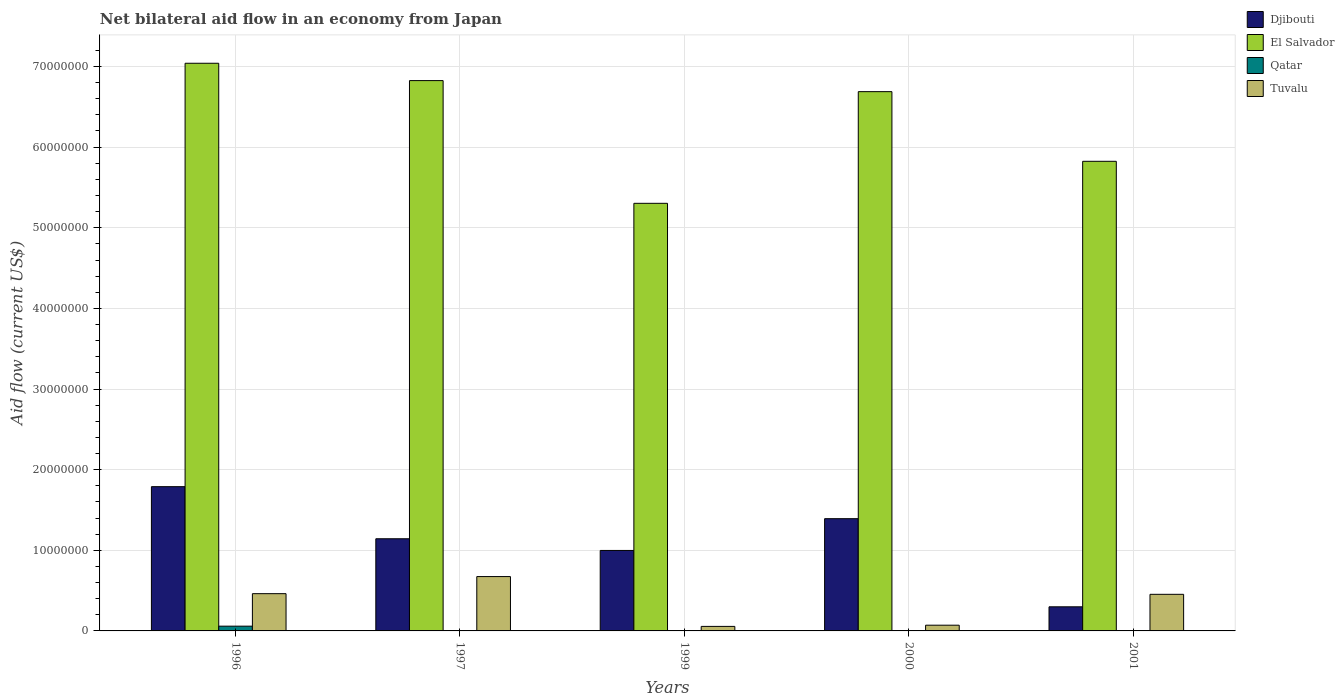Are the number of bars per tick equal to the number of legend labels?
Keep it short and to the point. Yes. Are the number of bars on each tick of the X-axis equal?
Keep it short and to the point. Yes. In how many cases, is the number of bars for a given year not equal to the number of legend labels?
Give a very brief answer. 0. What is the net bilateral aid flow in Djibouti in 2001?
Offer a very short reply. 2.99e+06. Across all years, what is the maximum net bilateral aid flow in Djibouti?
Give a very brief answer. 1.79e+07. Across all years, what is the minimum net bilateral aid flow in El Salvador?
Your response must be concise. 5.30e+07. In which year was the net bilateral aid flow in Djibouti maximum?
Your answer should be very brief. 1996. What is the total net bilateral aid flow in Tuvalu in the graph?
Offer a terse response. 1.72e+07. What is the difference between the net bilateral aid flow in El Salvador in 1999 and that in 2001?
Your answer should be very brief. -5.21e+06. What is the difference between the net bilateral aid flow in Tuvalu in 2000 and the net bilateral aid flow in Djibouti in 1997?
Provide a short and direct response. -1.07e+07. What is the average net bilateral aid flow in Qatar per year?
Keep it short and to the point. 1.40e+05. In the year 2000, what is the difference between the net bilateral aid flow in El Salvador and net bilateral aid flow in Qatar?
Keep it short and to the point. 6.68e+07. In how many years, is the net bilateral aid flow in Djibouti greater than 68000000 US$?
Provide a short and direct response. 0. What is the ratio of the net bilateral aid flow in Djibouti in 1999 to that in 2000?
Provide a succinct answer. 0.72. Is the net bilateral aid flow in Djibouti in 1996 less than that in 1997?
Provide a succinct answer. No. Is the difference between the net bilateral aid flow in El Salvador in 1999 and 2001 greater than the difference between the net bilateral aid flow in Qatar in 1999 and 2001?
Your response must be concise. No. What is the difference between the highest and the second highest net bilateral aid flow in Djibouti?
Provide a succinct answer. 3.97e+06. What is the difference between the highest and the lowest net bilateral aid flow in Qatar?
Your answer should be compact. 5.80e+05. In how many years, is the net bilateral aid flow in Tuvalu greater than the average net bilateral aid flow in Tuvalu taken over all years?
Keep it short and to the point. 3. Is it the case that in every year, the sum of the net bilateral aid flow in Tuvalu and net bilateral aid flow in Djibouti is greater than the sum of net bilateral aid flow in Qatar and net bilateral aid flow in El Salvador?
Keep it short and to the point. Yes. What does the 2nd bar from the left in 2001 represents?
Give a very brief answer. El Salvador. What does the 2nd bar from the right in 1999 represents?
Your response must be concise. Qatar. How many bars are there?
Keep it short and to the point. 20. Are the values on the major ticks of Y-axis written in scientific E-notation?
Your answer should be very brief. No. Does the graph contain any zero values?
Ensure brevity in your answer.  No. Does the graph contain grids?
Keep it short and to the point. Yes. How many legend labels are there?
Ensure brevity in your answer.  4. What is the title of the graph?
Offer a very short reply. Net bilateral aid flow in an economy from Japan. What is the label or title of the Y-axis?
Your answer should be compact. Aid flow (current US$). What is the Aid flow (current US$) of Djibouti in 1996?
Your response must be concise. 1.79e+07. What is the Aid flow (current US$) in El Salvador in 1996?
Your answer should be very brief. 7.04e+07. What is the Aid flow (current US$) of Qatar in 1996?
Offer a very short reply. 5.90e+05. What is the Aid flow (current US$) of Tuvalu in 1996?
Offer a very short reply. 4.62e+06. What is the Aid flow (current US$) of Djibouti in 1997?
Keep it short and to the point. 1.14e+07. What is the Aid flow (current US$) in El Salvador in 1997?
Provide a succinct answer. 6.82e+07. What is the Aid flow (current US$) in Qatar in 1997?
Your answer should be compact. 2.00e+04. What is the Aid flow (current US$) in Tuvalu in 1997?
Give a very brief answer. 6.74e+06. What is the Aid flow (current US$) of Djibouti in 1999?
Provide a short and direct response. 9.98e+06. What is the Aid flow (current US$) in El Salvador in 1999?
Keep it short and to the point. 5.30e+07. What is the Aid flow (current US$) of Qatar in 1999?
Give a very brief answer. 3.00e+04. What is the Aid flow (current US$) in Tuvalu in 1999?
Your answer should be compact. 5.60e+05. What is the Aid flow (current US$) of Djibouti in 2000?
Provide a succinct answer. 1.39e+07. What is the Aid flow (current US$) of El Salvador in 2000?
Make the answer very short. 6.69e+07. What is the Aid flow (current US$) in Tuvalu in 2000?
Provide a succinct answer. 7.10e+05. What is the Aid flow (current US$) in Djibouti in 2001?
Ensure brevity in your answer.  2.99e+06. What is the Aid flow (current US$) of El Salvador in 2001?
Your answer should be compact. 5.82e+07. What is the Aid flow (current US$) of Tuvalu in 2001?
Your response must be concise. 4.54e+06. Across all years, what is the maximum Aid flow (current US$) in Djibouti?
Your answer should be compact. 1.79e+07. Across all years, what is the maximum Aid flow (current US$) in El Salvador?
Ensure brevity in your answer.  7.04e+07. Across all years, what is the maximum Aid flow (current US$) of Qatar?
Offer a terse response. 5.90e+05. Across all years, what is the maximum Aid flow (current US$) in Tuvalu?
Your answer should be compact. 6.74e+06. Across all years, what is the minimum Aid flow (current US$) in Djibouti?
Offer a very short reply. 2.99e+06. Across all years, what is the minimum Aid flow (current US$) of El Salvador?
Keep it short and to the point. 5.30e+07. Across all years, what is the minimum Aid flow (current US$) of Tuvalu?
Your answer should be very brief. 5.60e+05. What is the total Aid flow (current US$) of Djibouti in the graph?
Give a very brief answer. 5.62e+07. What is the total Aid flow (current US$) in El Salvador in the graph?
Make the answer very short. 3.17e+08. What is the total Aid flow (current US$) of Tuvalu in the graph?
Offer a very short reply. 1.72e+07. What is the difference between the Aid flow (current US$) of Djibouti in 1996 and that in 1997?
Provide a short and direct response. 6.46e+06. What is the difference between the Aid flow (current US$) of El Salvador in 1996 and that in 1997?
Offer a terse response. 2.15e+06. What is the difference between the Aid flow (current US$) in Qatar in 1996 and that in 1997?
Offer a very short reply. 5.70e+05. What is the difference between the Aid flow (current US$) in Tuvalu in 1996 and that in 1997?
Your answer should be very brief. -2.12e+06. What is the difference between the Aid flow (current US$) of Djibouti in 1996 and that in 1999?
Offer a terse response. 7.91e+06. What is the difference between the Aid flow (current US$) in El Salvador in 1996 and that in 1999?
Your answer should be very brief. 1.74e+07. What is the difference between the Aid flow (current US$) in Qatar in 1996 and that in 1999?
Your answer should be compact. 5.60e+05. What is the difference between the Aid flow (current US$) of Tuvalu in 1996 and that in 1999?
Make the answer very short. 4.06e+06. What is the difference between the Aid flow (current US$) in Djibouti in 1996 and that in 2000?
Offer a terse response. 3.97e+06. What is the difference between the Aid flow (current US$) of El Salvador in 1996 and that in 2000?
Provide a succinct answer. 3.52e+06. What is the difference between the Aid flow (current US$) of Qatar in 1996 and that in 2000?
Offer a terse response. 5.40e+05. What is the difference between the Aid flow (current US$) of Tuvalu in 1996 and that in 2000?
Ensure brevity in your answer.  3.91e+06. What is the difference between the Aid flow (current US$) of Djibouti in 1996 and that in 2001?
Your answer should be very brief. 1.49e+07. What is the difference between the Aid flow (current US$) of El Salvador in 1996 and that in 2001?
Offer a terse response. 1.22e+07. What is the difference between the Aid flow (current US$) in Qatar in 1996 and that in 2001?
Your response must be concise. 5.80e+05. What is the difference between the Aid flow (current US$) of Djibouti in 1997 and that in 1999?
Your answer should be very brief. 1.45e+06. What is the difference between the Aid flow (current US$) in El Salvador in 1997 and that in 1999?
Offer a terse response. 1.52e+07. What is the difference between the Aid flow (current US$) of Tuvalu in 1997 and that in 1999?
Ensure brevity in your answer.  6.18e+06. What is the difference between the Aid flow (current US$) in Djibouti in 1997 and that in 2000?
Your answer should be compact. -2.49e+06. What is the difference between the Aid flow (current US$) in El Salvador in 1997 and that in 2000?
Your answer should be very brief. 1.37e+06. What is the difference between the Aid flow (current US$) in Tuvalu in 1997 and that in 2000?
Your answer should be very brief. 6.03e+06. What is the difference between the Aid flow (current US$) of Djibouti in 1997 and that in 2001?
Offer a very short reply. 8.44e+06. What is the difference between the Aid flow (current US$) in El Salvador in 1997 and that in 2001?
Ensure brevity in your answer.  1.00e+07. What is the difference between the Aid flow (current US$) in Qatar in 1997 and that in 2001?
Provide a short and direct response. 10000. What is the difference between the Aid flow (current US$) of Tuvalu in 1997 and that in 2001?
Make the answer very short. 2.20e+06. What is the difference between the Aid flow (current US$) of Djibouti in 1999 and that in 2000?
Give a very brief answer. -3.94e+06. What is the difference between the Aid flow (current US$) in El Salvador in 1999 and that in 2000?
Offer a very short reply. -1.38e+07. What is the difference between the Aid flow (current US$) in Qatar in 1999 and that in 2000?
Your answer should be very brief. -2.00e+04. What is the difference between the Aid flow (current US$) of Tuvalu in 1999 and that in 2000?
Make the answer very short. -1.50e+05. What is the difference between the Aid flow (current US$) of Djibouti in 1999 and that in 2001?
Offer a very short reply. 6.99e+06. What is the difference between the Aid flow (current US$) of El Salvador in 1999 and that in 2001?
Ensure brevity in your answer.  -5.21e+06. What is the difference between the Aid flow (current US$) of Tuvalu in 1999 and that in 2001?
Offer a terse response. -3.98e+06. What is the difference between the Aid flow (current US$) of Djibouti in 2000 and that in 2001?
Offer a very short reply. 1.09e+07. What is the difference between the Aid flow (current US$) of El Salvador in 2000 and that in 2001?
Give a very brief answer. 8.64e+06. What is the difference between the Aid flow (current US$) in Tuvalu in 2000 and that in 2001?
Ensure brevity in your answer.  -3.83e+06. What is the difference between the Aid flow (current US$) in Djibouti in 1996 and the Aid flow (current US$) in El Salvador in 1997?
Provide a succinct answer. -5.04e+07. What is the difference between the Aid flow (current US$) of Djibouti in 1996 and the Aid flow (current US$) of Qatar in 1997?
Make the answer very short. 1.79e+07. What is the difference between the Aid flow (current US$) of Djibouti in 1996 and the Aid flow (current US$) of Tuvalu in 1997?
Your answer should be compact. 1.12e+07. What is the difference between the Aid flow (current US$) in El Salvador in 1996 and the Aid flow (current US$) in Qatar in 1997?
Make the answer very short. 7.04e+07. What is the difference between the Aid flow (current US$) in El Salvador in 1996 and the Aid flow (current US$) in Tuvalu in 1997?
Make the answer very short. 6.37e+07. What is the difference between the Aid flow (current US$) of Qatar in 1996 and the Aid flow (current US$) of Tuvalu in 1997?
Keep it short and to the point. -6.15e+06. What is the difference between the Aid flow (current US$) in Djibouti in 1996 and the Aid flow (current US$) in El Salvador in 1999?
Make the answer very short. -3.51e+07. What is the difference between the Aid flow (current US$) of Djibouti in 1996 and the Aid flow (current US$) of Qatar in 1999?
Your answer should be very brief. 1.79e+07. What is the difference between the Aid flow (current US$) of Djibouti in 1996 and the Aid flow (current US$) of Tuvalu in 1999?
Your response must be concise. 1.73e+07. What is the difference between the Aid flow (current US$) of El Salvador in 1996 and the Aid flow (current US$) of Qatar in 1999?
Give a very brief answer. 7.04e+07. What is the difference between the Aid flow (current US$) of El Salvador in 1996 and the Aid flow (current US$) of Tuvalu in 1999?
Make the answer very short. 6.98e+07. What is the difference between the Aid flow (current US$) of Djibouti in 1996 and the Aid flow (current US$) of El Salvador in 2000?
Keep it short and to the point. -4.90e+07. What is the difference between the Aid flow (current US$) in Djibouti in 1996 and the Aid flow (current US$) in Qatar in 2000?
Your answer should be very brief. 1.78e+07. What is the difference between the Aid flow (current US$) of Djibouti in 1996 and the Aid flow (current US$) of Tuvalu in 2000?
Provide a short and direct response. 1.72e+07. What is the difference between the Aid flow (current US$) in El Salvador in 1996 and the Aid flow (current US$) in Qatar in 2000?
Your answer should be compact. 7.04e+07. What is the difference between the Aid flow (current US$) in El Salvador in 1996 and the Aid flow (current US$) in Tuvalu in 2000?
Ensure brevity in your answer.  6.97e+07. What is the difference between the Aid flow (current US$) of Djibouti in 1996 and the Aid flow (current US$) of El Salvador in 2001?
Keep it short and to the point. -4.04e+07. What is the difference between the Aid flow (current US$) in Djibouti in 1996 and the Aid flow (current US$) in Qatar in 2001?
Keep it short and to the point. 1.79e+07. What is the difference between the Aid flow (current US$) in Djibouti in 1996 and the Aid flow (current US$) in Tuvalu in 2001?
Ensure brevity in your answer.  1.34e+07. What is the difference between the Aid flow (current US$) of El Salvador in 1996 and the Aid flow (current US$) of Qatar in 2001?
Give a very brief answer. 7.04e+07. What is the difference between the Aid flow (current US$) in El Salvador in 1996 and the Aid flow (current US$) in Tuvalu in 2001?
Offer a very short reply. 6.59e+07. What is the difference between the Aid flow (current US$) in Qatar in 1996 and the Aid flow (current US$) in Tuvalu in 2001?
Provide a succinct answer. -3.95e+06. What is the difference between the Aid flow (current US$) of Djibouti in 1997 and the Aid flow (current US$) of El Salvador in 1999?
Offer a terse response. -4.16e+07. What is the difference between the Aid flow (current US$) in Djibouti in 1997 and the Aid flow (current US$) in Qatar in 1999?
Your answer should be compact. 1.14e+07. What is the difference between the Aid flow (current US$) in Djibouti in 1997 and the Aid flow (current US$) in Tuvalu in 1999?
Give a very brief answer. 1.09e+07. What is the difference between the Aid flow (current US$) in El Salvador in 1997 and the Aid flow (current US$) in Qatar in 1999?
Your answer should be very brief. 6.82e+07. What is the difference between the Aid flow (current US$) of El Salvador in 1997 and the Aid flow (current US$) of Tuvalu in 1999?
Ensure brevity in your answer.  6.77e+07. What is the difference between the Aid flow (current US$) in Qatar in 1997 and the Aid flow (current US$) in Tuvalu in 1999?
Your answer should be very brief. -5.40e+05. What is the difference between the Aid flow (current US$) of Djibouti in 1997 and the Aid flow (current US$) of El Salvador in 2000?
Provide a short and direct response. -5.54e+07. What is the difference between the Aid flow (current US$) of Djibouti in 1997 and the Aid flow (current US$) of Qatar in 2000?
Make the answer very short. 1.14e+07. What is the difference between the Aid flow (current US$) in Djibouti in 1997 and the Aid flow (current US$) in Tuvalu in 2000?
Make the answer very short. 1.07e+07. What is the difference between the Aid flow (current US$) in El Salvador in 1997 and the Aid flow (current US$) in Qatar in 2000?
Give a very brief answer. 6.82e+07. What is the difference between the Aid flow (current US$) of El Salvador in 1997 and the Aid flow (current US$) of Tuvalu in 2000?
Offer a terse response. 6.75e+07. What is the difference between the Aid flow (current US$) in Qatar in 1997 and the Aid flow (current US$) in Tuvalu in 2000?
Your answer should be very brief. -6.90e+05. What is the difference between the Aid flow (current US$) in Djibouti in 1997 and the Aid flow (current US$) in El Salvador in 2001?
Make the answer very short. -4.68e+07. What is the difference between the Aid flow (current US$) in Djibouti in 1997 and the Aid flow (current US$) in Qatar in 2001?
Your answer should be very brief. 1.14e+07. What is the difference between the Aid flow (current US$) in Djibouti in 1997 and the Aid flow (current US$) in Tuvalu in 2001?
Offer a terse response. 6.89e+06. What is the difference between the Aid flow (current US$) of El Salvador in 1997 and the Aid flow (current US$) of Qatar in 2001?
Your response must be concise. 6.82e+07. What is the difference between the Aid flow (current US$) in El Salvador in 1997 and the Aid flow (current US$) in Tuvalu in 2001?
Make the answer very short. 6.37e+07. What is the difference between the Aid flow (current US$) of Qatar in 1997 and the Aid flow (current US$) of Tuvalu in 2001?
Make the answer very short. -4.52e+06. What is the difference between the Aid flow (current US$) of Djibouti in 1999 and the Aid flow (current US$) of El Salvador in 2000?
Offer a very short reply. -5.69e+07. What is the difference between the Aid flow (current US$) in Djibouti in 1999 and the Aid flow (current US$) in Qatar in 2000?
Ensure brevity in your answer.  9.93e+06. What is the difference between the Aid flow (current US$) in Djibouti in 1999 and the Aid flow (current US$) in Tuvalu in 2000?
Make the answer very short. 9.27e+06. What is the difference between the Aid flow (current US$) of El Salvador in 1999 and the Aid flow (current US$) of Qatar in 2000?
Your answer should be compact. 5.30e+07. What is the difference between the Aid flow (current US$) in El Salvador in 1999 and the Aid flow (current US$) in Tuvalu in 2000?
Offer a terse response. 5.23e+07. What is the difference between the Aid flow (current US$) of Qatar in 1999 and the Aid flow (current US$) of Tuvalu in 2000?
Keep it short and to the point. -6.80e+05. What is the difference between the Aid flow (current US$) of Djibouti in 1999 and the Aid flow (current US$) of El Salvador in 2001?
Offer a terse response. -4.83e+07. What is the difference between the Aid flow (current US$) of Djibouti in 1999 and the Aid flow (current US$) of Qatar in 2001?
Keep it short and to the point. 9.97e+06. What is the difference between the Aid flow (current US$) in Djibouti in 1999 and the Aid flow (current US$) in Tuvalu in 2001?
Your answer should be compact. 5.44e+06. What is the difference between the Aid flow (current US$) of El Salvador in 1999 and the Aid flow (current US$) of Qatar in 2001?
Offer a very short reply. 5.30e+07. What is the difference between the Aid flow (current US$) in El Salvador in 1999 and the Aid flow (current US$) in Tuvalu in 2001?
Provide a short and direct response. 4.85e+07. What is the difference between the Aid flow (current US$) of Qatar in 1999 and the Aid flow (current US$) of Tuvalu in 2001?
Provide a succinct answer. -4.51e+06. What is the difference between the Aid flow (current US$) in Djibouti in 2000 and the Aid flow (current US$) in El Salvador in 2001?
Provide a succinct answer. -4.43e+07. What is the difference between the Aid flow (current US$) of Djibouti in 2000 and the Aid flow (current US$) of Qatar in 2001?
Make the answer very short. 1.39e+07. What is the difference between the Aid flow (current US$) of Djibouti in 2000 and the Aid flow (current US$) of Tuvalu in 2001?
Your answer should be compact. 9.38e+06. What is the difference between the Aid flow (current US$) of El Salvador in 2000 and the Aid flow (current US$) of Qatar in 2001?
Your answer should be very brief. 6.69e+07. What is the difference between the Aid flow (current US$) of El Salvador in 2000 and the Aid flow (current US$) of Tuvalu in 2001?
Keep it short and to the point. 6.23e+07. What is the difference between the Aid flow (current US$) in Qatar in 2000 and the Aid flow (current US$) in Tuvalu in 2001?
Make the answer very short. -4.49e+06. What is the average Aid flow (current US$) of Djibouti per year?
Provide a succinct answer. 1.12e+07. What is the average Aid flow (current US$) in El Salvador per year?
Ensure brevity in your answer.  6.34e+07. What is the average Aid flow (current US$) of Qatar per year?
Your answer should be very brief. 1.40e+05. What is the average Aid flow (current US$) in Tuvalu per year?
Offer a very short reply. 3.43e+06. In the year 1996, what is the difference between the Aid flow (current US$) of Djibouti and Aid flow (current US$) of El Salvador?
Your response must be concise. -5.25e+07. In the year 1996, what is the difference between the Aid flow (current US$) in Djibouti and Aid flow (current US$) in Qatar?
Make the answer very short. 1.73e+07. In the year 1996, what is the difference between the Aid flow (current US$) in Djibouti and Aid flow (current US$) in Tuvalu?
Keep it short and to the point. 1.33e+07. In the year 1996, what is the difference between the Aid flow (current US$) in El Salvador and Aid flow (current US$) in Qatar?
Provide a succinct answer. 6.98e+07. In the year 1996, what is the difference between the Aid flow (current US$) in El Salvador and Aid flow (current US$) in Tuvalu?
Your answer should be very brief. 6.58e+07. In the year 1996, what is the difference between the Aid flow (current US$) of Qatar and Aid flow (current US$) of Tuvalu?
Provide a short and direct response. -4.03e+06. In the year 1997, what is the difference between the Aid flow (current US$) of Djibouti and Aid flow (current US$) of El Salvador?
Offer a very short reply. -5.68e+07. In the year 1997, what is the difference between the Aid flow (current US$) in Djibouti and Aid flow (current US$) in Qatar?
Provide a succinct answer. 1.14e+07. In the year 1997, what is the difference between the Aid flow (current US$) in Djibouti and Aid flow (current US$) in Tuvalu?
Provide a succinct answer. 4.69e+06. In the year 1997, what is the difference between the Aid flow (current US$) in El Salvador and Aid flow (current US$) in Qatar?
Offer a very short reply. 6.82e+07. In the year 1997, what is the difference between the Aid flow (current US$) of El Salvador and Aid flow (current US$) of Tuvalu?
Your answer should be very brief. 6.15e+07. In the year 1997, what is the difference between the Aid flow (current US$) of Qatar and Aid flow (current US$) of Tuvalu?
Your answer should be very brief. -6.72e+06. In the year 1999, what is the difference between the Aid flow (current US$) of Djibouti and Aid flow (current US$) of El Salvador?
Make the answer very short. -4.30e+07. In the year 1999, what is the difference between the Aid flow (current US$) of Djibouti and Aid flow (current US$) of Qatar?
Offer a terse response. 9.95e+06. In the year 1999, what is the difference between the Aid flow (current US$) of Djibouti and Aid flow (current US$) of Tuvalu?
Your response must be concise. 9.42e+06. In the year 1999, what is the difference between the Aid flow (current US$) in El Salvador and Aid flow (current US$) in Qatar?
Ensure brevity in your answer.  5.30e+07. In the year 1999, what is the difference between the Aid flow (current US$) of El Salvador and Aid flow (current US$) of Tuvalu?
Your answer should be very brief. 5.25e+07. In the year 1999, what is the difference between the Aid flow (current US$) of Qatar and Aid flow (current US$) of Tuvalu?
Give a very brief answer. -5.30e+05. In the year 2000, what is the difference between the Aid flow (current US$) of Djibouti and Aid flow (current US$) of El Salvador?
Make the answer very short. -5.30e+07. In the year 2000, what is the difference between the Aid flow (current US$) in Djibouti and Aid flow (current US$) in Qatar?
Provide a succinct answer. 1.39e+07. In the year 2000, what is the difference between the Aid flow (current US$) of Djibouti and Aid flow (current US$) of Tuvalu?
Give a very brief answer. 1.32e+07. In the year 2000, what is the difference between the Aid flow (current US$) of El Salvador and Aid flow (current US$) of Qatar?
Offer a very short reply. 6.68e+07. In the year 2000, what is the difference between the Aid flow (current US$) in El Salvador and Aid flow (current US$) in Tuvalu?
Ensure brevity in your answer.  6.62e+07. In the year 2000, what is the difference between the Aid flow (current US$) of Qatar and Aid flow (current US$) of Tuvalu?
Give a very brief answer. -6.60e+05. In the year 2001, what is the difference between the Aid flow (current US$) in Djibouti and Aid flow (current US$) in El Salvador?
Offer a very short reply. -5.52e+07. In the year 2001, what is the difference between the Aid flow (current US$) in Djibouti and Aid flow (current US$) in Qatar?
Your response must be concise. 2.98e+06. In the year 2001, what is the difference between the Aid flow (current US$) in Djibouti and Aid flow (current US$) in Tuvalu?
Your answer should be very brief. -1.55e+06. In the year 2001, what is the difference between the Aid flow (current US$) in El Salvador and Aid flow (current US$) in Qatar?
Your answer should be very brief. 5.82e+07. In the year 2001, what is the difference between the Aid flow (current US$) in El Salvador and Aid flow (current US$) in Tuvalu?
Your response must be concise. 5.37e+07. In the year 2001, what is the difference between the Aid flow (current US$) in Qatar and Aid flow (current US$) in Tuvalu?
Provide a succinct answer. -4.53e+06. What is the ratio of the Aid flow (current US$) in Djibouti in 1996 to that in 1997?
Provide a short and direct response. 1.57. What is the ratio of the Aid flow (current US$) in El Salvador in 1996 to that in 1997?
Provide a succinct answer. 1.03. What is the ratio of the Aid flow (current US$) in Qatar in 1996 to that in 1997?
Offer a terse response. 29.5. What is the ratio of the Aid flow (current US$) of Tuvalu in 1996 to that in 1997?
Ensure brevity in your answer.  0.69. What is the ratio of the Aid flow (current US$) of Djibouti in 1996 to that in 1999?
Your answer should be very brief. 1.79. What is the ratio of the Aid flow (current US$) of El Salvador in 1996 to that in 1999?
Offer a very short reply. 1.33. What is the ratio of the Aid flow (current US$) in Qatar in 1996 to that in 1999?
Make the answer very short. 19.67. What is the ratio of the Aid flow (current US$) in Tuvalu in 1996 to that in 1999?
Offer a terse response. 8.25. What is the ratio of the Aid flow (current US$) of Djibouti in 1996 to that in 2000?
Provide a short and direct response. 1.29. What is the ratio of the Aid flow (current US$) of El Salvador in 1996 to that in 2000?
Your answer should be compact. 1.05. What is the ratio of the Aid flow (current US$) in Qatar in 1996 to that in 2000?
Provide a short and direct response. 11.8. What is the ratio of the Aid flow (current US$) of Tuvalu in 1996 to that in 2000?
Make the answer very short. 6.51. What is the ratio of the Aid flow (current US$) in Djibouti in 1996 to that in 2001?
Ensure brevity in your answer.  5.98. What is the ratio of the Aid flow (current US$) in El Salvador in 1996 to that in 2001?
Offer a terse response. 1.21. What is the ratio of the Aid flow (current US$) of Tuvalu in 1996 to that in 2001?
Your response must be concise. 1.02. What is the ratio of the Aid flow (current US$) in Djibouti in 1997 to that in 1999?
Offer a very short reply. 1.15. What is the ratio of the Aid flow (current US$) in El Salvador in 1997 to that in 1999?
Provide a short and direct response. 1.29. What is the ratio of the Aid flow (current US$) in Qatar in 1997 to that in 1999?
Keep it short and to the point. 0.67. What is the ratio of the Aid flow (current US$) of Tuvalu in 1997 to that in 1999?
Make the answer very short. 12.04. What is the ratio of the Aid flow (current US$) in Djibouti in 1997 to that in 2000?
Your answer should be very brief. 0.82. What is the ratio of the Aid flow (current US$) of El Salvador in 1997 to that in 2000?
Make the answer very short. 1.02. What is the ratio of the Aid flow (current US$) in Qatar in 1997 to that in 2000?
Your answer should be compact. 0.4. What is the ratio of the Aid flow (current US$) of Tuvalu in 1997 to that in 2000?
Offer a terse response. 9.49. What is the ratio of the Aid flow (current US$) of Djibouti in 1997 to that in 2001?
Ensure brevity in your answer.  3.82. What is the ratio of the Aid flow (current US$) of El Salvador in 1997 to that in 2001?
Offer a very short reply. 1.17. What is the ratio of the Aid flow (current US$) of Qatar in 1997 to that in 2001?
Your response must be concise. 2. What is the ratio of the Aid flow (current US$) of Tuvalu in 1997 to that in 2001?
Provide a short and direct response. 1.48. What is the ratio of the Aid flow (current US$) in Djibouti in 1999 to that in 2000?
Provide a short and direct response. 0.72. What is the ratio of the Aid flow (current US$) of El Salvador in 1999 to that in 2000?
Make the answer very short. 0.79. What is the ratio of the Aid flow (current US$) of Tuvalu in 1999 to that in 2000?
Provide a short and direct response. 0.79. What is the ratio of the Aid flow (current US$) in Djibouti in 1999 to that in 2001?
Provide a short and direct response. 3.34. What is the ratio of the Aid flow (current US$) in El Salvador in 1999 to that in 2001?
Provide a succinct answer. 0.91. What is the ratio of the Aid flow (current US$) of Tuvalu in 1999 to that in 2001?
Your answer should be compact. 0.12. What is the ratio of the Aid flow (current US$) in Djibouti in 2000 to that in 2001?
Offer a very short reply. 4.66. What is the ratio of the Aid flow (current US$) in El Salvador in 2000 to that in 2001?
Ensure brevity in your answer.  1.15. What is the ratio of the Aid flow (current US$) of Tuvalu in 2000 to that in 2001?
Provide a short and direct response. 0.16. What is the difference between the highest and the second highest Aid flow (current US$) in Djibouti?
Provide a succinct answer. 3.97e+06. What is the difference between the highest and the second highest Aid flow (current US$) of El Salvador?
Ensure brevity in your answer.  2.15e+06. What is the difference between the highest and the second highest Aid flow (current US$) in Qatar?
Provide a succinct answer. 5.40e+05. What is the difference between the highest and the second highest Aid flow (current US$) of Tuvalu?
Give a very brief answer. 2.12e+06. What is the difference between the highest and the lowest Aid flow (current US$) in Djibouti?
Keep it short and to the point. 1.49e+07. What is the difference between the highest and the lowest Aid flow (current US$) in El Salvador?
Offer a very short reply. 1.74e+07. What is the difference between the highest and the lowest Aid flow (current US$) of Qatar?
Offer a very short reply. 5.80e+05. What is the difference between the highest and the lowest Aid flow (current US$) in Tuvalu?
Provide a short and direct response. 6.18e+06. 